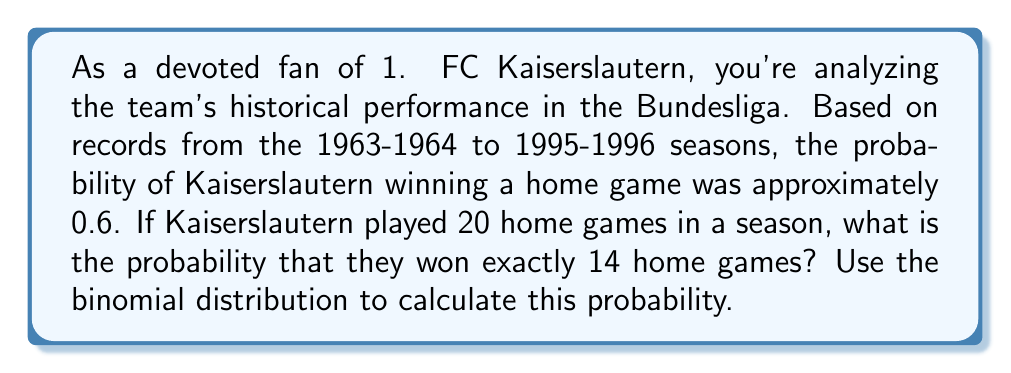Can you solve this math problem? To solve this problem, we'll use the binomial distribution formula. The binomial distribution is used when we have a fixed number of independent trials (n), each with the same probability of success (p).

In this case:
- n = 20 (number of home games)
- k = 14 (number of wins we're interested in)
- p = 0.6 (probability of winning a home game)
- q = 1 - p = 0.4 (probability of not winning a home game)

The binomial probability formula is:

$$ P(X = k) = \binom{n}{k} p^k (1-p)^{n-k} $$

Where $\binom{n}{k}$ is the binomial coefficient, calculated as:

$$ \binom{n}{k} = \frac{n!}{k!(n-k)!} $$

Let's calculate step by step:

1) First, calculate the binomial coefficient:

   $\binom{20}{14} = \frac{20!}{14!(20-14)!} = \frac{20!}{14!6!} = 38,760$

2) Now, let's plug everything into the binomial probability formula:

   $$ P(X = 14) = 38,760 \cdot (0.6)^{14} \cdot (0.4)^{6} $$

3) Calculate the powers:
   $(0.6)^{14} \approx 0.0006879$
   $(0.4)^6 \approx 0.0041$

4) Multiply all parts together:
   $38,760 \cdot 0.0006879 \cdot 0.0041 \approx 0.1093$

Therefore, the probability of 1. FC Kaiserslautern winning exactly 14 out of 20 home games in a season is approximately 0.1093 or 10.93%.
Answer: $P(X = 14) \approx 0.1093$ or $10.93\%$ 